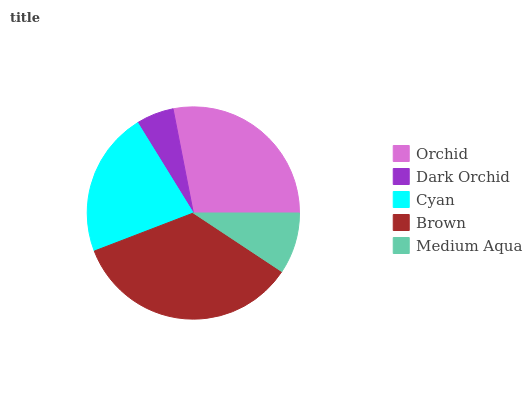Is Dark Orchid the minimum?
Answer yes or no. Yes. Is Brown the maximum?
Answer yes or no. Yes. Is Cyan the minimum?
Answer yes or no. No. Is Cyan the maximum?
Answer yes or no. No. Is Cyan greater than Dark Orchid?
Answer yes or no. Yes. Is Dark Orchid less than Cyan?
Answer yes or no. Yes. Is Dark Orchid greater than Cyan?
Answer yes or no. No. Is Cyan less than Dark Orchid?
Answer yes or no. No. Is Cyan the high median?
Answer yes or no. Yes. Is Cyan the low median?
Answer yes or no. Yes. Is Medium Aqua the high median?
Answer yes or no. No. Is Dark Orchid the low median?
Answer yes or no. No. 